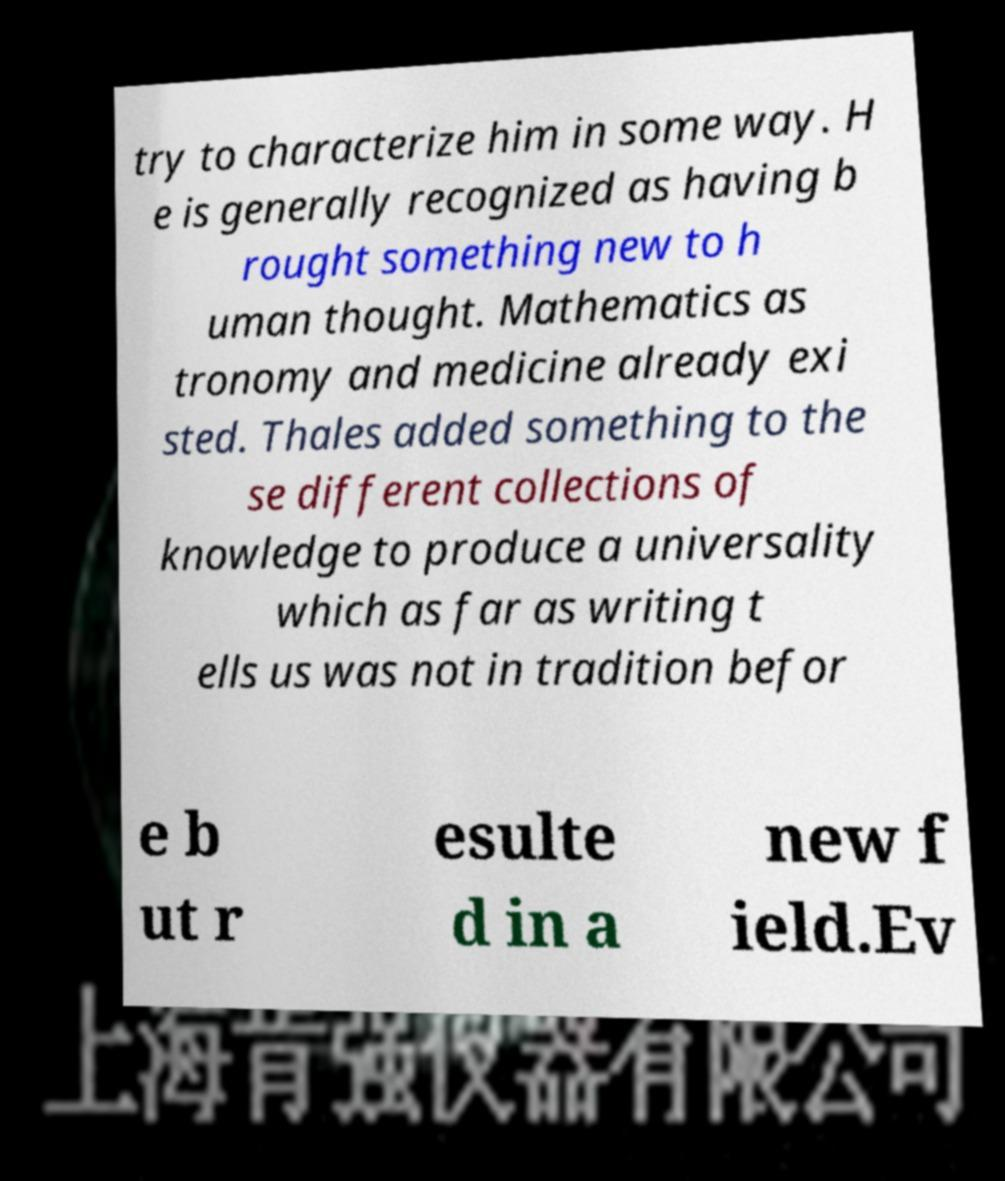There's text embedded in this image that I need extracted. Can you transcribe it verbatim? try to characterize him in some way. H e is generally recognized as having b rought something new to h uman thought. Mathematics as tronomy and medicine already exi sted. Thales added something to the se different collections of knowledge to produce a universality which as far as writing t ells us was not in tradition befor e b ut r esulte d in a new f ield.Ev 